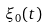<formula> <loc_0><loc_0><loc_500><loc_500>\xi _ { 0 } ( t )</formula> 